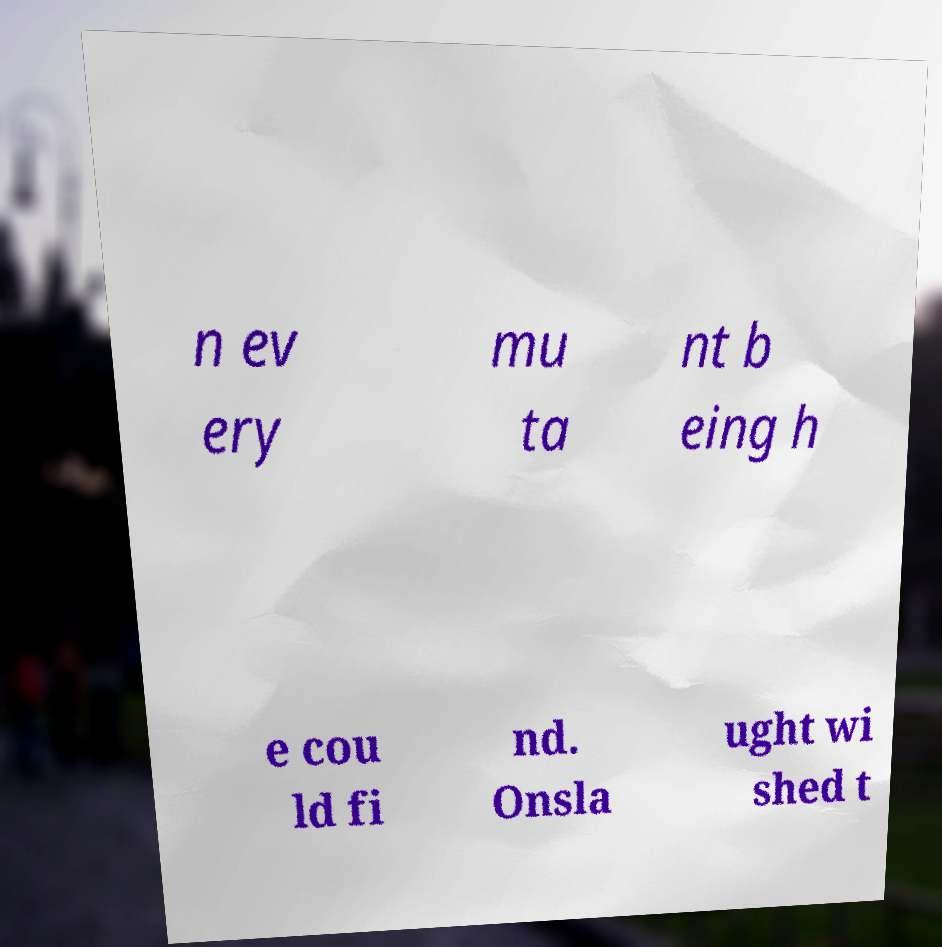Could you assist in decoding the text presented in this image and type it out clearly? n ev ery mu ta nt b eing h e cou ld fi nd. Onsla ught wi shed t 